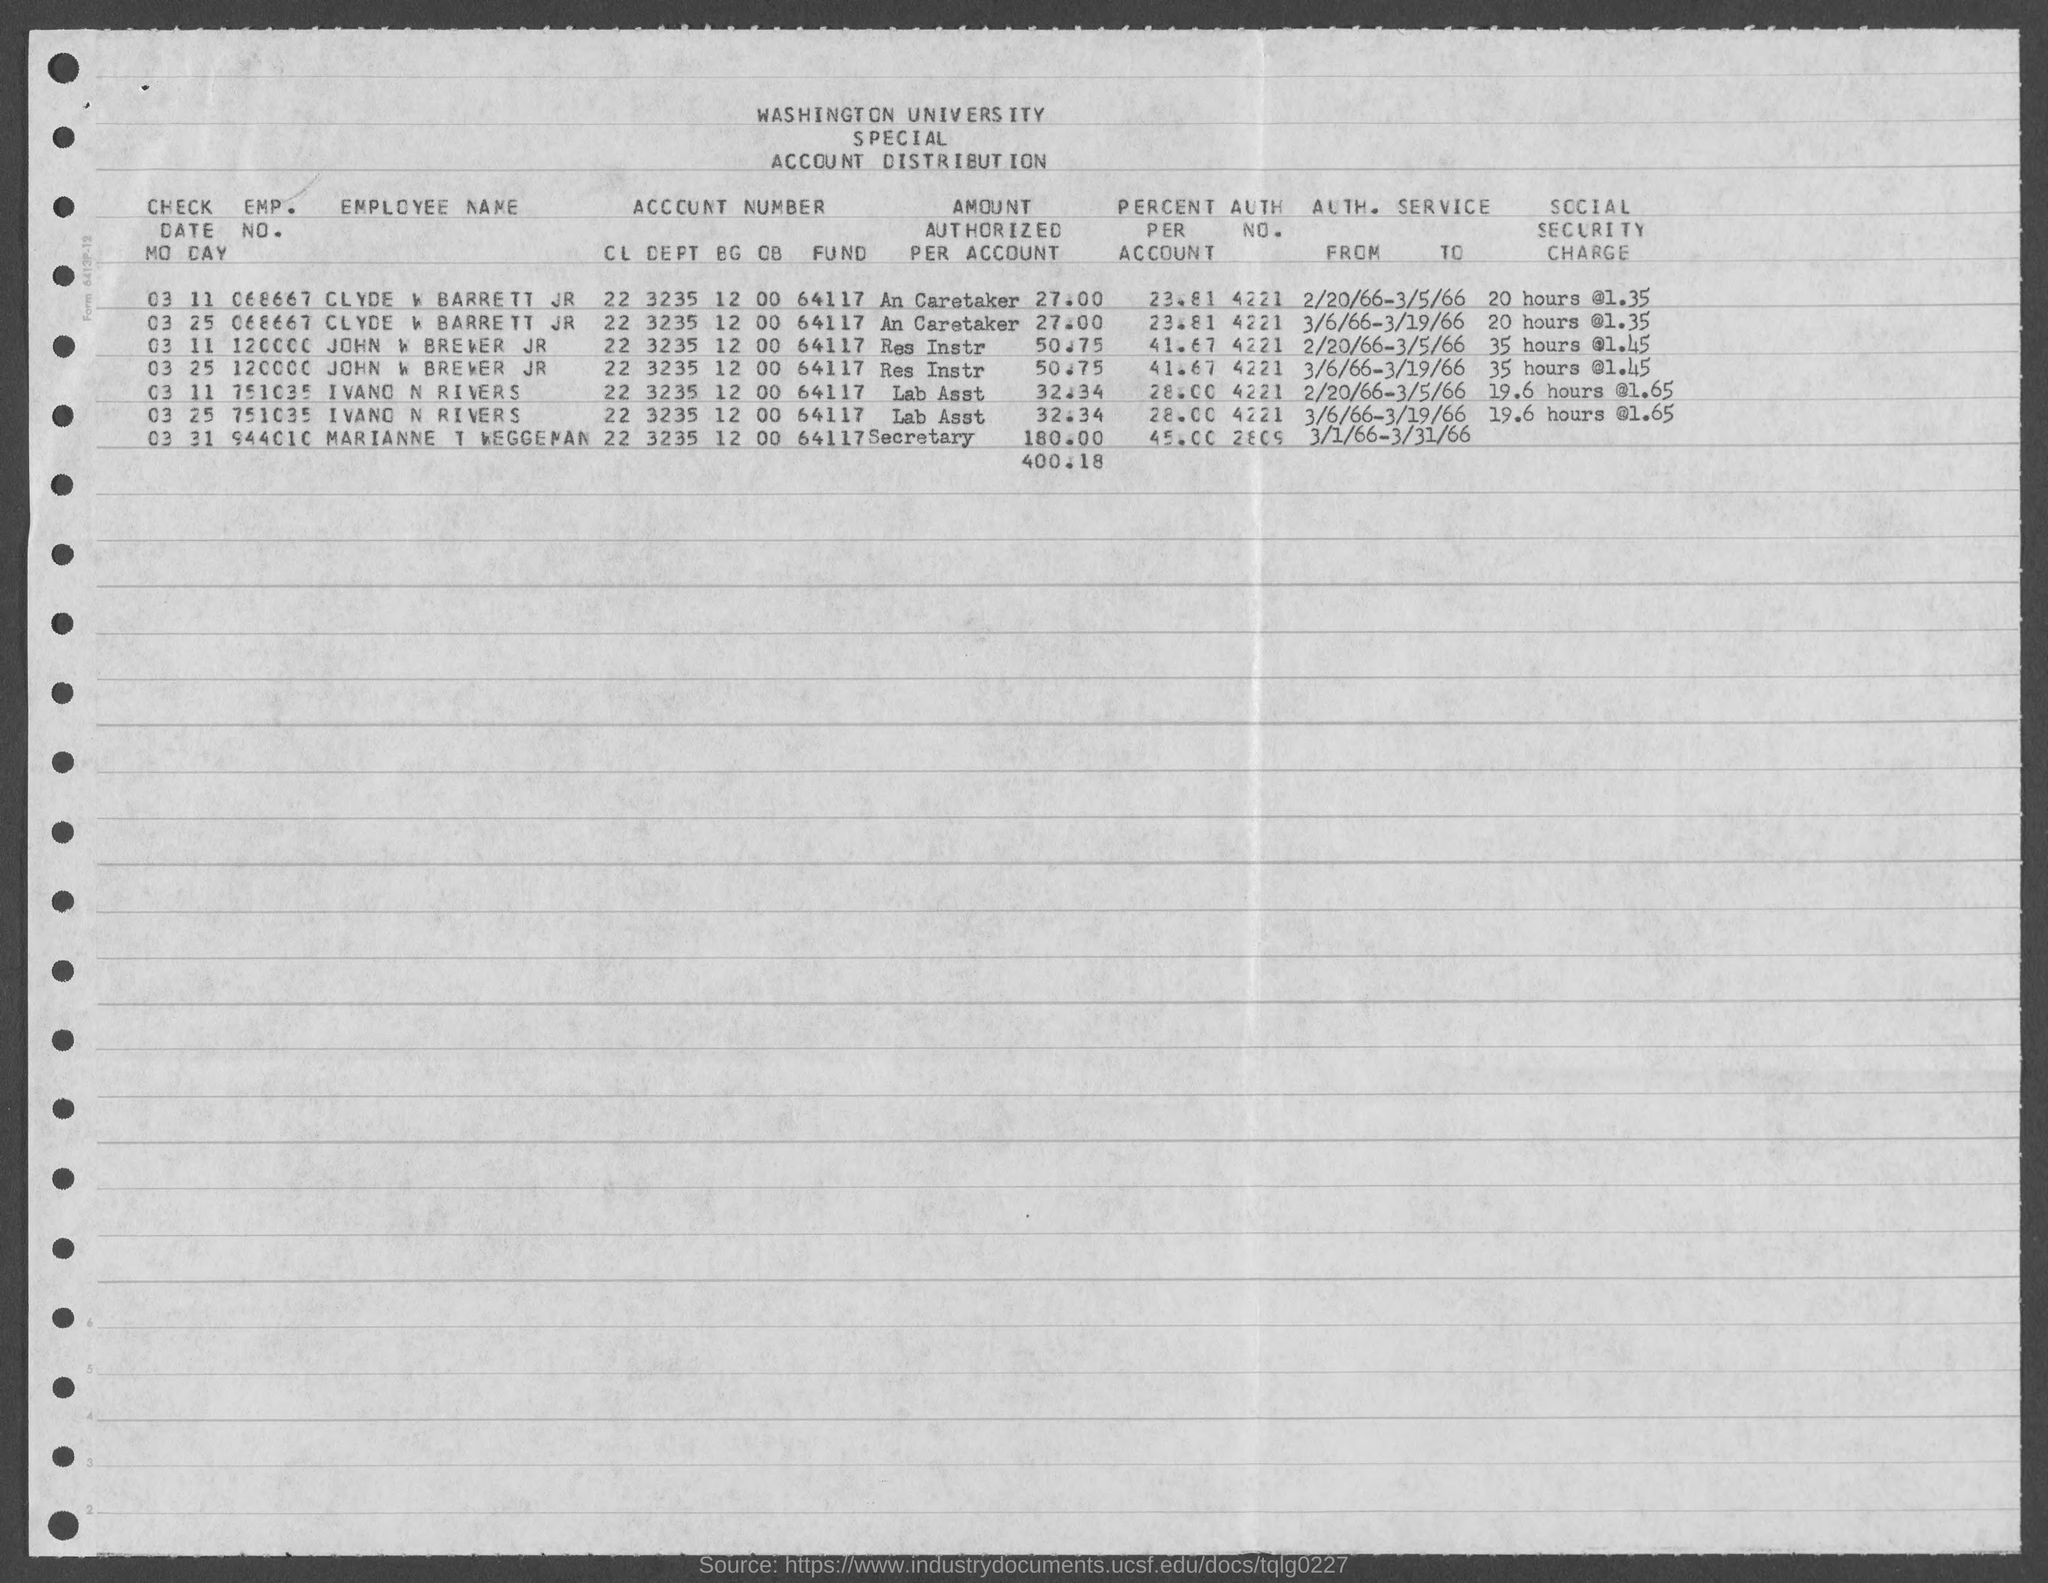Point out several critical features in this image. The employee number of Ivano N Rivers is 751035. John W Brewer Jr's authorization number is 4221. John W. Brewer Jr.'s employment number is 120000. The percent per person of Ivano N Rivers is 28.00... The percentage per person of Marianne T Weggeman is 45.00... 